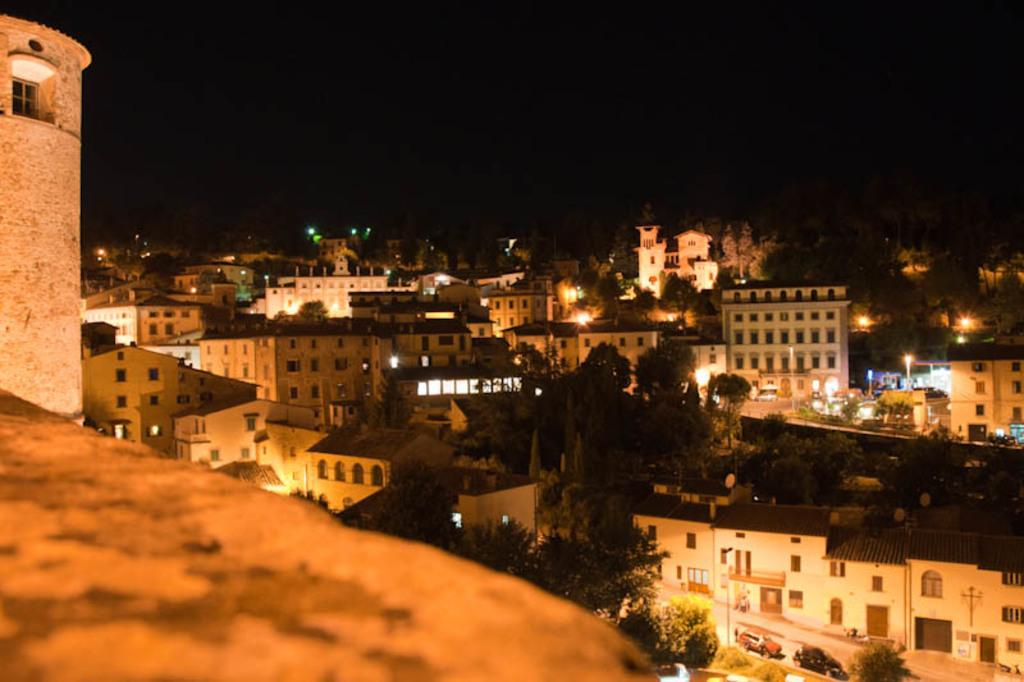What type of structures are visible in the image? There are buildings in the image. What other natural elements can be seen in the image? There are trees in the image. What are the sources of illumination in the image? There are lights in the image. How many cars are visible at the bottom of the image? There are two cars at the bottom of the image. What is visible at the top of the image? The sky is visible at the top of the image. Where is the desk located in the image? There is no desk present in the image. What type of competition is taking place in the image? There is no competition present in the image. 